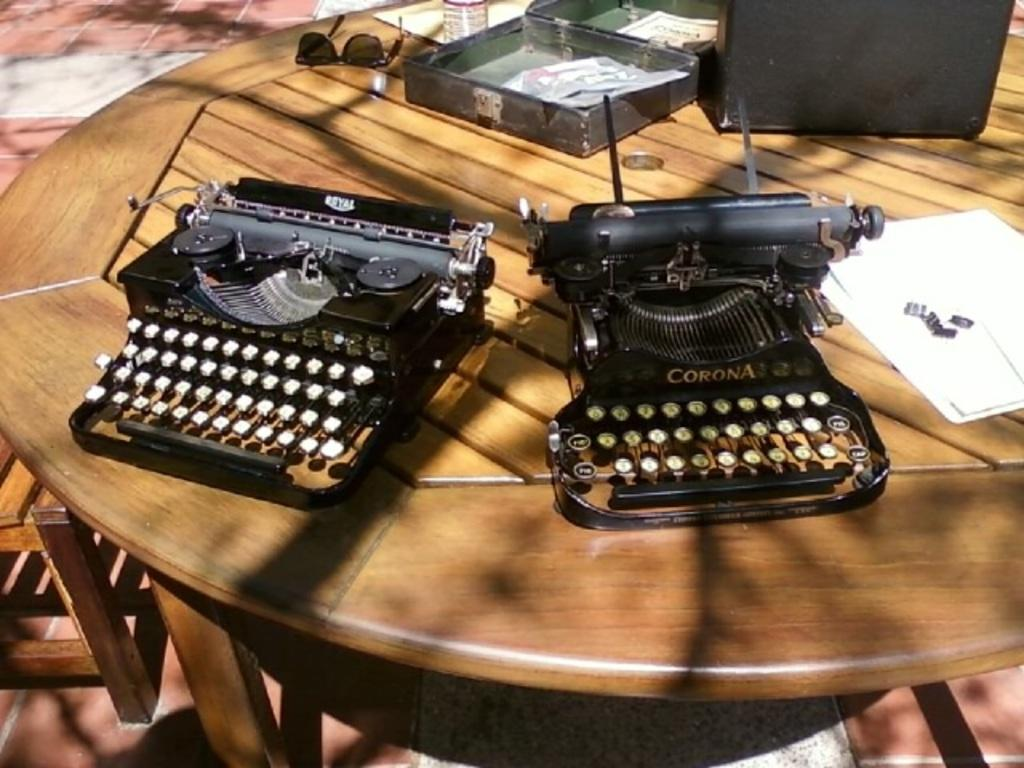<image>
Render a clear and concise summary of the photo. A Corona typewriter sits on a round wooden table outside. 